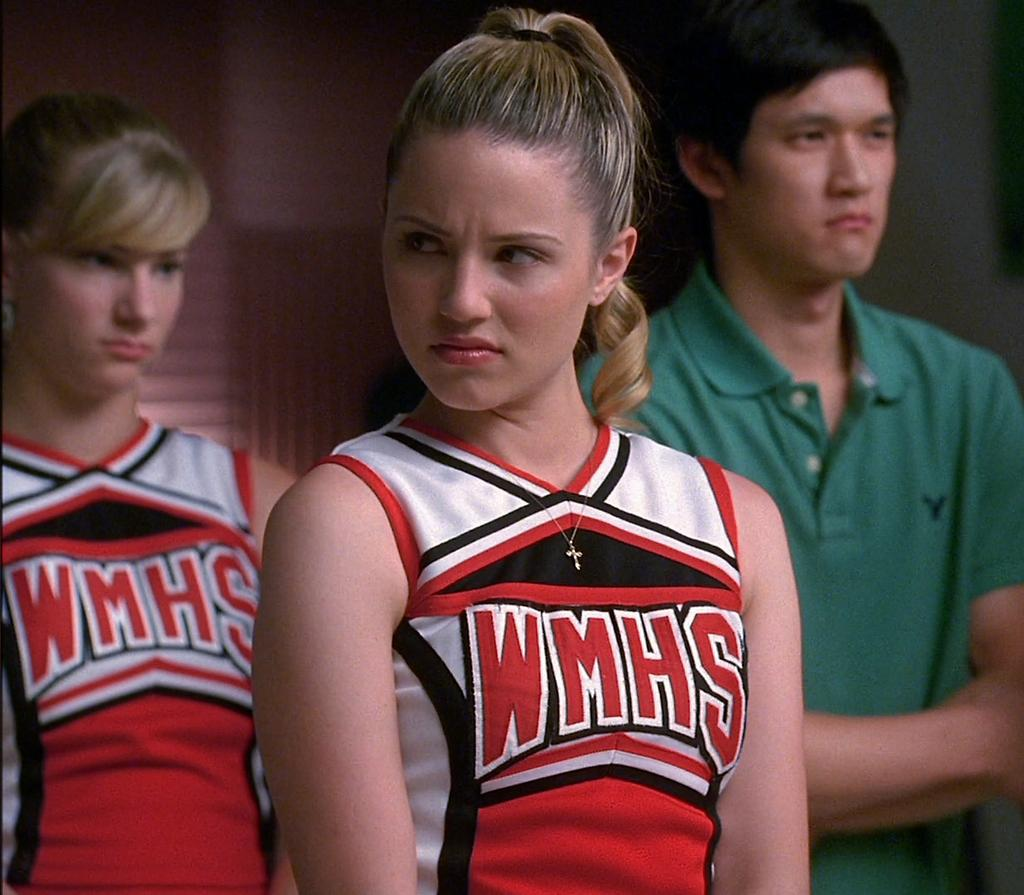Provide a one-sentence caption for the provided image. Cheerleader wearing a top that says WMHS on it. 